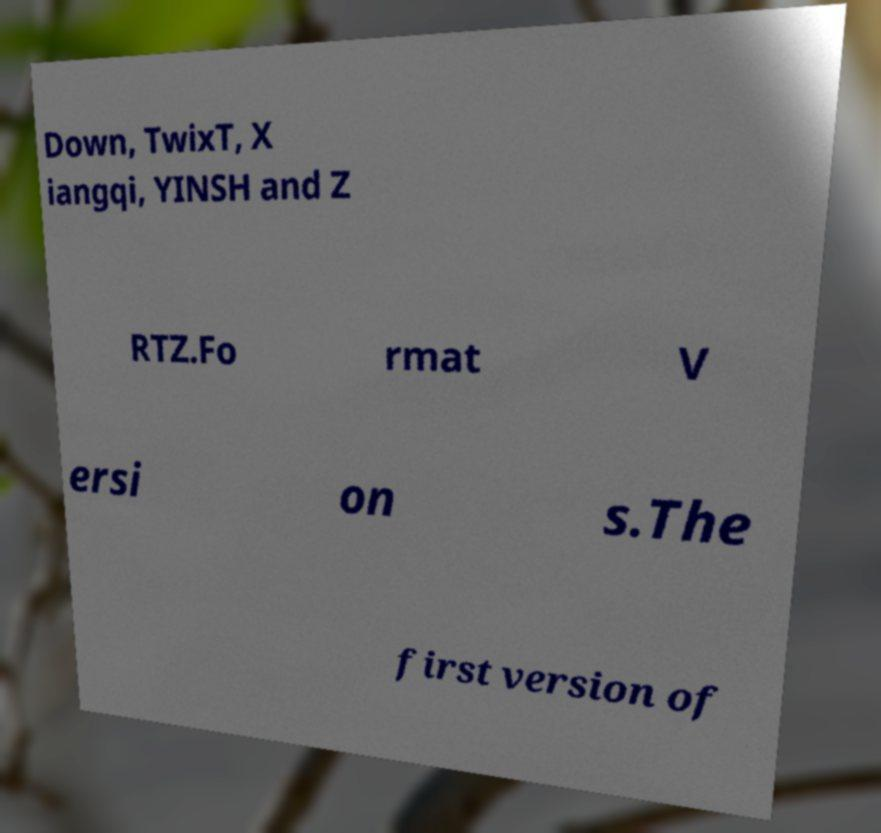What messages or text are displayed in this image? I need them in a readable, typed format. Down, TwixT, X iangqi, YINSH and Z RTZ.Fo rmat V ersi on s.The first version of 